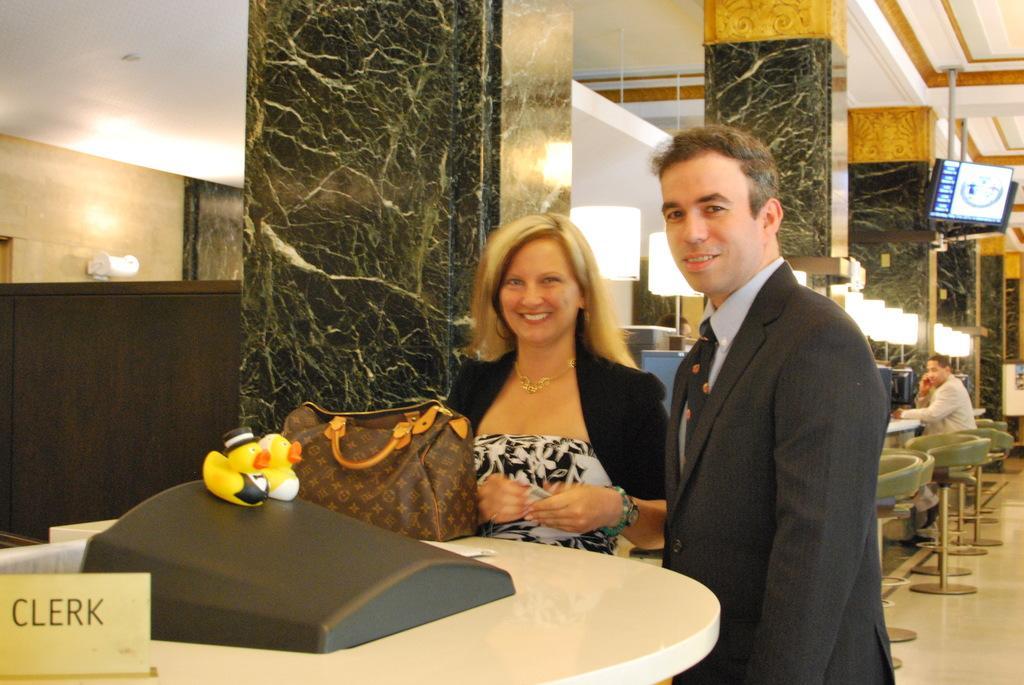Describe this image in one or two sentences. In the image there is a man stood beside a woman in front of table,the place seems to in a hotel. 